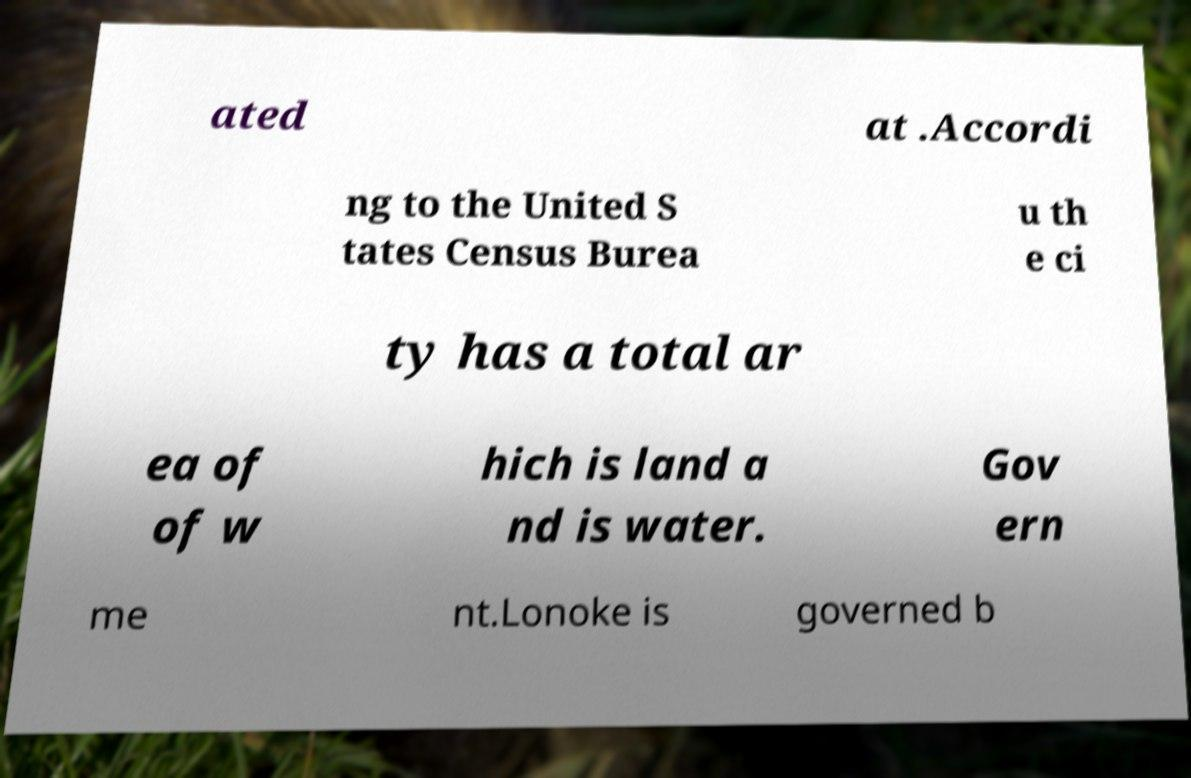Could you extract and type out the text from this image? ated at .Accordi ng to the United S tates Census Burea u th e ci ty has a total ar ea of of w hich is land a nd is water. Gov ern me nt.Lonoke is governed b 